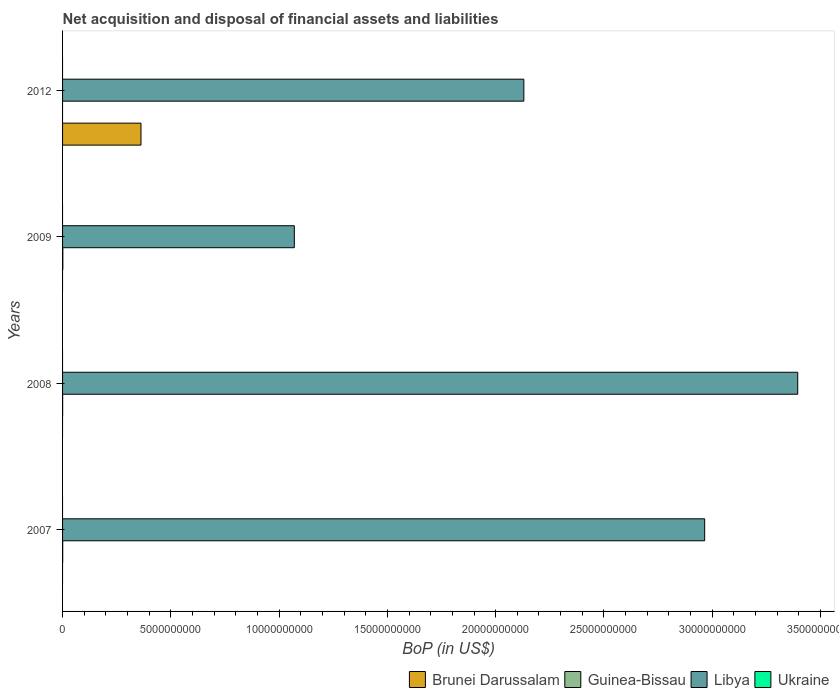How many different coloured bars are there?
Give a very brief answer. 3. Are the number of bars per tick equal to the number of legend labels?
Ensure brevity in your answer.  No. What is the label of the 1st group of bars from the top?
Provide a succinct answer. 2012. What is the Balance of Payments in Guinea-Bissau in 2007?
Your response must be concise. 6.67e+06. Across all years, what is the maximum Balance of Payments in Brunei Darussalam?
Offer a very short reply. 3.62e+09. Across all years, what is the minimum Balance of Payments in Brunei Darussalam?
Offer a very short reply. 0. In which year was the Balance of Payments in Guinea-Bissau maximum?
Your answer should be compact. 2009. What is the total Balance of Payments in Ukraine in the graph?
Provide a succinct answer. 0. What is the difference between the Balance of Payments in Libya in 2007 and that in 2008?
Your answer should be compact. -4.30e+09. What is the difference between the Balance of Payments in Guinea-Bissau in 2007 and the Balance of Payments in Brunei Darussalam in 2012?
Offer a very short reply. -3.61e+09. What is the average Balance of Payments in Brunei Darussalam per year?
Offer a very short reply. 9.05e+08. In the year 2007, what is the difference between the Balance of Payments in Libya and Balance of Payments in Guinea-Bissau?
Ensure brevity in your answer.  2.96e+1. In how many years, is the Balance of Payments in Libya greater than 27000000000 US$?
Your answer should be very brief. 2. What is the ratio of the Balance of Payments in Libya in 2007 to that in 2009?
Your answer should be very brief. 2.77. Is the Balance of Payments in Libya in 2008 less than that in 2009?
Ensure brevity in your answer.  No. Is the difference between the Balance of Payments in Libya in 2007 and 2008 greater than the difference between the Balance of Payments in Guinea-Bissau in 2007 and 2008?
Offer a very short reply. No. What is the difference between the highest and the second highest Balance of Payments in Libya?
Your answer should be very brief. 4.30e+09. What is the difference between the highest and the lowest Balance of Payments in Libya?
Provide a short and direct response. 2.32e+1. In how many years, is the Balance of Payments in Brunei Darussalam greater than the average Balance of Payments in Brunei Darussalam taken over all years?
Give a very brief answer. 1. Is it the case that in every year, the sum of the Balance of Payments in Brunei Darussalam and Balance of Payments in Guinea-Bissau is greater than the sum of Balance of Payments in Ukraine and Balance of Payments in Libya?
Make the answer very short. No. How many bars are there?
Make the answer very short. 8. Are all the bars in the graph horizontal?
Provide a succinct answer. Yes. How many years are there in the graph?
Offer a terse response. 4. Does the graph contain grids?
Offer a terse response. No. What is the title of the graph?
Give a very brief answer. Net acquisition and disposal of financial assets and liabilities. What is the label or title of the X-axis?
Offer a very short reply. BoP (in US$). What is the label or title of the Y-axis?
Keep it short and to the point. Years. What is the BoP (in US$) of Guinea-Bissau in 2007?
Your answer should be compact. 6.67e+06. What is the BoP (in US$) of Libya in 2007?
Your response must be concise. 2.97e+1. What is the BoP (in US$) of Brunei Darussalam in 2008?
Give a very brief answer. 0. What is the BoP (in US$) in Guinea-Bissau in 2008?
Ensure brevity in your answer.  3.15e+06. What is the BoP (in US$) of Libya in 2008?
Keep it short and to the point. 3.39e+1. What is the BoP (in US$) of Brunei Darussalam in 2009?
Provide a succinct answer. 0. What is the BoP (in US$) in Guinea-Bissau in 2009?
Keep it short and to the point. 1.22e+07. What is the BoP (in US$) in Libya in 2009?
Give a very brief answer. 1.07e+1. What is the BoP (in US$) of Brunei Darussalam in 2012?
Provide a short and direct response. 3.62e+09. What is the BoP (in US$) of Guinea-Bissau in 2012?
Your response must be concise. 0. What is the BoP (in US$) in Libya in 2012?
Offer a terse response. 2.13e+1. Across all years, what is the maximum BoP (in US$) of Brunei Darussalam?
Ensure brevity in your answer.  3.62e+09. Across all years, what is the maximum BoP (in US$) in Guinea-Bissau?
Give a very brief answer. 1.22e+07. Across all years, what is the maximum BoP (in US$) in Libya?
Your answer should be compact. 3.39e+1. Across all years, what is the minimum BoP (in US$) of Guinea-Bissau?
Your answer should be very brief. 0. Across all years, what is the minimum BoP (in US$) of Libya?
Keep it short and to the point. 1.07e+1. What is the total BoP (in US$) in Brunei Darussalam in the graph?
Make the answer very short. 3.62e+09. What is the total BoP (in US$) in Guinea-Bissau in the graph?
Make the answer very short. 2.20e+07. What is the total BoP (in US$) of Libya in the graph?
Your answer should be very brief. 9.56e+1. What is the total BoP (in US$) in Ukraine in the graph?
Ensure brevity in your answer.  0. What is the difference between the BoP (in US$) of Guinea-Bissau in 2007 and that in 2008?
Your answer should be very brief. 3.52e+06. What is the difference between the BoP (in US$) of Libya in 2007 and that in 2008?
Ensure brevity in your answer.  -4.30e+09. What is the difference between the BoP (in US$) of Guinea-Bissau in 2007 and that in 2009?
Provide a succinct answer. -5.49e+06. What is the difference between the BoP (in US$) of Libya in 2007 and that in 2009?
Ensure brevity in your answer.  1.89e+1. What is the difference between the BoP (in US$) of Libya in 2007 and that in 2012?
Ensure brevity in your answer.  8.35e+09. What is the difference between the BoP (in US$) of Guinea-Bissau in 2008 and that in 2009?
Provide a succinct answer. -9.01e+06. What is the difference between the BoP (in US$) of Libya in 2008 and that in 2009?
Provide a succinct answer. 2.32e+1. What is the difference between the BoP (in US$) of Libya in 2008 and that in 2012?
Ensure brevity in your answer.  1.26e+1. What is the difference between the BoP (in US$) in Libya in 2009 and that in 2012?
Offer a very short reply. -1.06e+1. What is the difference between the BoP (in US$) of Guinea-Bissau in 2007 and the BoP (in US$) of Libya in 2008?
Give a very brief answer. -3.39e+1. What is the difference between the BoP (in US$) in Guinea-Bissau in 2007 and the BoP (in US$) in Libya in 2009?
Keep it short and to the point. -1.07e+1. What is the difference between the BoP (in US$) of Guinea-Bissau in 2007 and the BoP (in US$) of Libya in 2012?
Offer a terse response. -2.13e+1. What is the difference between the BoP (in US$) of Guinea-Bissau in 2008 and the BoP (in US$) of Libya in 2009?
Give a very brief answer. -1.07e+1. What is the difference between the BoP (in US$) in Guinea-Bissau in 2008 and the BoP (in US$) in Libya in 2012?
Provide a succinct answer. -2.13e+1. What is the difference between the BoP (in US$) in Guinea-Bissau in 2009 and the BoP (in US$) in Libya in 2012?
Your response must be concise. -2.13e+1. What is the average BoP (in US$) in Brunei Darussalam per year?
Ensure brevity in your answer.  9.05e+08. What is the average BoP (in US$) in Guinea-Bissau per year?
Offer a terse response. 5.50e+06. What is the average BoP (in US$) of Libya per year?
Your answer should be very brief. 2.39e+1. What is the average BoP (in US$) in Ukraine per year?
Your answer should be very brief. 0. In the year 2007, what is the difference between the BoP (in US$) in Guinea-Bissau and BoP (in US$) in Libya?
Make the answer very short. -2.96e+1. In the year 2008, what is the difference between the BoP (in US$) of Guinea-Bissau and BoP (in US$) of Libya?
Provide a succinct answer. -3.39e+1. In the year 2009, what is the difference between the BoP (in US$) of Guinea-Bissau and BoP (in US$) of Libya?
Ensure brevity in your answer.  -1.07e+1. In the year 2012, what is the difference between the BoP (in US$) of Brunei Darussalam and BoP (in US$) of Libya?
Make the answer very short. -1.77e+1. What is the ratio of the BoP (in US$) of Guinea-Bissau in 2007 to that in 2008?
Your response must be concise. 2.12. What is the ratio of the BoP (in US$) in Libya in 2007 to that in 2008?
Keep it short and to the point. 0.87. What is the ratio of the BoP (in US$) in Guinea-Bissau in 2007 to that in 2009?
Make the answer very short. 0.55. What is the ratio of the BoP (in US$) in Libya in 2007 to that in 2009?
Provide a succinct answer. 2.77. What is the ratio of the BoP (in US$) in Libya in 2007 to that in 2012?
Provide a short and direct response. 1.39. What is the ratio of the BoP (in US$) of Guinea-Bissau in 2008 to that in 2009?
Give a very brief answer. 0.26. What is the ratio of the BoP (in US$) of Libya in 2008 to that in 2009?
Your answer should be compact. 3.17. What is the ratio of the BoP (in US$) of Libya in 2008 to that in 2012?
Give a very brief answer. 1.59. What is the ratio of the BoP (in US$) in Libya in 2009 to that in 2012?
Your answer should be very brief. 0.5. What is the difference between the highest and the second highest BoP (in US$) in Guinea-Bissau?
Provide a succinct answer. 5.49e+06. What is the difference between the highest and the second highest BoP (in US$) in Libya?
Your response must be concise. 4.30e+09. What is the difference between the highest and the lowest BoP (in US$) of Brunei Darussalam?
Provide a short and direct response. 3.62e+09. What is the difference between the highest and the lowest BoP (in US$) of Guinea-Bissau?
Your answer should be compact. 1.22e+07. What is the difference between the highest and the lowest BoP (in US$) in Libya?
Keep it short and to the point. 2.32e+1. 